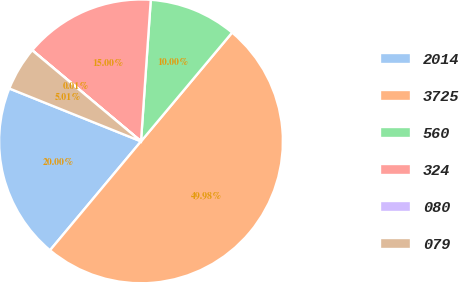Convert chart to OTSL. <chart><loc_0><loc_0><loc_500><loc_500><pie_chart><fcel>2014<fcel>3725<fcel>560<fcel>324<fcel>080<fcel>079<nl><fcel>20.0%<fcel>49.98%<fcel>10.0%<fcel>15.0%<fcel>0.01%<fcel>5.01%<nl></chart> 